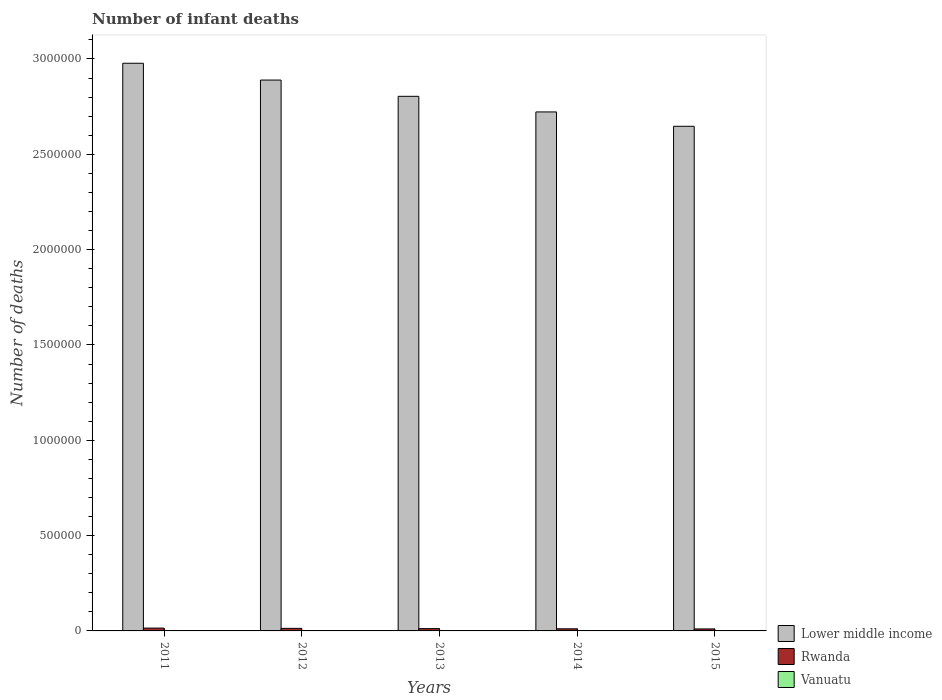How many groups of bars are there?
Make the answer very short. 5. Are the number of bars on each tick of the X-axis equal?
Ensure brevity in your answer.  Yes. How many bars are there on the 5th tick from the right?
Your response must be concise. 3. In how many cases, is the number of bars for a given year not equal to the number of legend labels?
Your answer should be compact. 0. What is the number of infant deaths in Lower middle income in 2015?
Keep it short and to the point. 2.65e+06. Across all years, what is the maximum number of infant deaths in Vanuatu?
Give a very brief answer. 187. Across all years, what is the minimum number of infant deaths in Vanuatu?
Make the answer very short. 157. In which year was the number of infant deaths in Lower middle income minimum?
Provide a short and direct response. 2015. What is the total number of infant deaths in Vanuatu in the graph?
Keep it short and to the point. 860. What is the difference between the number of infant deaths in Rwanda in 2012 and that in 2015?
Ensure brevity in your answer.  2923. What is the difference between the number of infant deaths in Rwanda in 2011 and the number of infant deaths in Vanuatu in 2015?
Ensure brevity in your answer.  1.46e+04. What is the average number of infant deaths in Lower middle income per year?
Provide a succinct answer. 2.81e+06. In the year 2012, what is the difference between the number of infant deaths in Rwanda and number of infant deaths in Vanuatu?
Make the answer very short. 1.32e+04. What is the ratio of the number of infant deaths in Rwanda in 2011 to that in 2014?
Make the answer very short. 1.33. Is the number of infant deaths in Vanuatu in 2012 less than that in 2015?
Keep it short and to the point. No. What is the difference between the highest and the lowest number of infant deaths in Lower middle income?
Provide a succinct answer. 3.31e+05. In how many years, is the number of infant deaths in Rwanda greater than the average number of infant deaths in Rwanda taken over all years?
Ensure brevity in your answer.  2. Is the sum of the number of infant deaths in Lower middle income in 2011 and 2013 greater than the maximum number of infant deaths in Vanuatu across all years?
Offer a very short reply. Yes. What does the 1st bar from the left in 2015 represents?
Keep it short and to the point. Lower middle income. What does the 3rd bar from the right in 2014 represents?
Your answer should be compact. Lower middle income. Are the values on the major ticks of Y-axis written in scientific E-notation?
Give a very brief answer. No. Does the graph contain any zero values?
Your answer should be very brief. No. Where does the legend appear in the graph?
Offer a terse response. Bottom right. How many legend labels are there?
Make the answer very short. 3. What is the title of the graph?
Provide a succinct answer. Number of infant deaths. What is the label or title of the X-axis?
Give a very brief answer. Years. What is the label or title of the Y-axis?
Keep it short and to the point. Number of deaths. What is the Number of deaths of Lower middle income in 2011?
Give a very brief answer. 2.98e+06. What is the Number of deaths in Rwanda in 2011?
Provide a short and direct response. 1.48e+04. What is the Number of deaths in Vanuatu in 2011?
Offer a very short reply. 187. What is the Number of deaths in Lower middle income in 2012?
Make the answer very short. 2.89e+06. What is the Number of deaths in Rwanda in 2012?
Your answer should be very brief. 1.34e+04. What is the Number of deaths in Vanuatu in 2012?
Provide a short and direct response. 181. What is the Number of deaths in Lower middle income in 2013?
Provide a short and direct response. 2.80e+06. What is the Number of deaths of Rwanda in 2013?
Your answer should be compact. 1.21e+04. What is the Number of deaths in Vanuatu in 2013?
Keep it short and to the point. 172. What is the Number of deaths of Lower middle income in 2014?
Your answer should be very brief. 2.72e+06. What is the Number of deaths of Rwanda in 2014?
Your response must be concise. 1.11e+04. What is the Number of deaths of Vanuatu in 2014?
Offer a very short reply. 163. What is the Number of deaths in Lower middle income in 2015?
Give a very brief answer. 2.65e+06. What is the Number of deaths of Rwanda in 2015?
Offer a very short reply. 1.04e+04. What is the Number of deaths in Vanuatu in 2015?
Your response must be concise. 157. Across all years, what is the maximum Number of deaths in Lower middle income?
Ensure brevity in your answer.  2.98e+06. Across all years, what is the maximum Number of deaths of Rwanda?
Your answer should be very brief. 1.48e+04. Across all years, what is the maximum Number of deaths of Vanuatu?
Give a very brief answer. 187. Across all years, what is the minimum Number of deaths in Lower middle income?
Offer a terse response. 2.65e+06. Across all years, what is the minimum Number of deaths in Rwanda?
Make the answer very short. 1.04e+04. Across all years, what is the minimum Number of deaths of Vanuatu?
Keep it short and to the point. 157. What is the total Number of deaths of Lower middle income in the graph?
Keep it short and to the point. 1.40e+07. What is the total Number of deaths of Rwanda in the graph?
Make the answer very short. 6.18e+04. What is the total Number of deaths in Vanuatu in the graph?
Provide a succinct answer. 860. What is the difference between the Number of deaths of Lower middle income in 2011 and that in 2012?
Offer a very short reply. 8.81e+04. What is the difference between the Number of deaths of Rwanda in 2011 and that in 2012?
Keep it short and to the point. 1383. What is the difference between the Number of deaths of Vanuatu in 2011 and that in 2012?
Offer a very short reply. 6. What is the difference between the Number of deaths in Lower middle income in 2011 and that in 2013?
Offer a terse response. 1.73e+05. What is the difference between the Number of deaths of Rwanda in 2011 and that in 2013?
Offer a terse response. 2629. What is the difference between the Number of deaths in Lower middle income in 2011 and that in 2014?
Your answer should be very brief. 2.55e+05. What is the difference between the Number of deaths in Rwanda in 2011 and that in 2014?
Provide a succinct answer. 3628. What is the difference between the Number of deaths in Vanuatu in 2011 and that in 2014?
Your response must be concise. 24. What is the difference between the Number of deaths in Lower middle income in 2011 and that in 2015?
Keep it short and to the point. 3.31e+05. What is the difference between the Number of deaths in Rwanda in 2011 and that in 2015?
Provide a succinct answer. 4306. What is the difference between the Number of deaths in Vanuatu in 2011 and that in 2015?
Provide a short and direct response. 30. What is the difference between the Number of deaths in Lower middle income in 2012 and that in 2013?
Ensure brevity in your answer.  8.53e+04. What is the difference between the Number of deaths in Rwanda in 2012 and that in 2013?
Make the answer very short. 1246. What is the difference between the Number of deaths in Vanuatu in 2012 and that in 2013?
Give a very brief answer. 9. What is the difference between the Number of deaths in Lower middle income in 2012 and that in 2014?
Offer a very short reply. 1.67e+05. What is the difference between the Number of deaths of Rwanda in 2012 and that in 2014?
Keep it short and to the point. 2245. What is the difference between the Number of deaths of Lower middle income in 2012 and that in 2015?
Provide a short and direct response. 2.43e+05. What is the difference between the Number of deaths of Rwanda in 2012 and that in 2015?
Offer a very short reply. 2923. What is the difference between the Number of deaths of Vanuatu in 2012 and that in 2015?
Make the answer very short. 24. What is the difference between the Number of deaths of Lower middle income in 2013 and that in 2014?
Make the answer very short. 8.19e+04. What is the difference between the Number of deaths in Rwanda in 2013 and that in 2014?
Ensure brevity in your answer.  999. What is the difference between the Number of deaths of Vanuatu in 2013 and that in 2014?
Your response must be concise. 9. What is the difference between the Number of deaths in Lower middle income in 2013 and that in 2015?
Your response must be concise. 1.57e+05. What is the difference between the Number of deaths of Rwanda in 2013 and that in 2015?
Make the answer very short. 1677. What is the difference between the Number of deaths of Lower middle income in 2014 and that in 2015?
Give a very brief answer. 7.53e+04. What is the difference between the Number of deaths in Rwanda in 2014 and that in 2015?
Keep it short and to the point. 678. What is the difference between the Number of deaths of Lower middle income in 2011 and the Number of deaths of Rwanda in 2012?
Your answer should be compact. 2.96e+06. What is the difference between the Number of deaths of Lower middle income in 2011 and the Number of deaths of Vanuatu in 2012?
Give a very brief answer. 2.98e+06. What is the difference between the Number of deaths in Rwanda in 2011 and the Number of deaths in Vanuatu in 2012?
Offer a terse response. 1.46e+04. What is the difference between the Number of deaths of Lower middle income in 2011 and the Number of deaths of Rwanda in 2013?
Your response must be concise. 2.97e+06. What is the difference between the Number of deaths in Lower middle income in 2011 and the Number of deaths in Vanuatu in 2013?
Provide a short and direct response. 2.98e+06. What is the difference between the Number of deaths of Rwanda in 2011 and the Number of deaths of Vanuatu in 2013?
Offer a terse response. 1.46e+04. What is the difference between the Number of deaths of Lower middle income in 2011 and the Number of deaths of Rwanda in 2014?
Offer a terse response. 2.97e+06. What is the difference between the Number of deaths of Lower middle income in 2011 and the Number of deaths of Vanuatu in 2014?
Make the answer very short. 2.98e+06. What is the difference between the Number of deaths of Rwanda in 2011 and the Number of deaths of Vanuatu in 2014?
Offer a very short reply. 1.46e+04. What is the difference between the Number of deaths in Lower middle income in 2011 and the Number of deaths in Rwanda in 2015?
Your answer should be very brief. 2.97e+06. What is the difference between the Number of deaths in Lower middle income in 2011 and the Number of deaths in Vanuatu in 2015?
Ensure brevity in your answer.  2.98e+06. What is the difference between the Number of deaths of Rwanda in 2011 and the Number of deaths of Vanuatu in 2015?
Your answer should be very brief. 1.46e+04. What is the difference between the Number of deaths of Lower middle income in 2012 and the Number of deaths of Rwanda in 2013?
Ensure brevity in your answer.  2.88e+06. What is the difference between the Number of deaths in Lower middle income in 2012 and the Number of deaths in Vanuatu in 2013?
Your answer should be compact. 2.89e+06. What is the difference between the Number of deaths in Rwanda in 2012 and the Number of deaths in Vanuatu in 2013?
Offer a terse response. 1.32e+04. What is the difference between the Number of deaths in Lower middle income in 2012 and the Number of deaths in Rwanda in 2014?
Provide a short and direct response. 2.88e+06. What is the difference between the Number of deaths in Lower middle income in 2012 and the Number of deaths in Vanuatu in 2014?
Offer a terse response. 2.89e+06. What is the difference between the Number of deaths of Rwanda in 2012 and the Number of deaths of Vanuatu in 2014?
Provide a succinct answer. 1.32e+04. What is the difference between the Number of deaths in Lower middle income in 2012 and the Number of deaths in Rwanda in 2015?
Offer a very short reply. 2.88e+06. What is the difference between the Number of deaths of Lower middle income in 2012 and the Number of deaths of Vanuatu in 2015?
Your answer should be compact. 2.89e+06. What is the difference between the Number of deaths of Rwanda in 2012 and the Number of deaths of Vanuatu in 2015?
Keep it short and to the point. 1.32e+04. What is the difference between the Number of deaths of Lower middle income in 2013 and the Number of deaths of Rwanda in 2014?
Offer a very short reply. 2.79e+06. What is the difference between the Number of deaths in Lower middle income in 2013 and the Number of deaths in Vanuatu in 2014?
Make the answer very short. 2.80e+06. What is the difference between the Number of deaths of Rwanda in 2013 and the Number of deaths of Vanuatu in 2014?
Offer a terse response. 1.20e+04. What is the difference between the Number of deaths in Lower middle income in 2013 and the Number of deaths in Rwanda in 2015?
Provide a short and direct response. 2.79e+06. What is the difference between the Number of deaths of Lower middle income in 2013 and the Number of deaths of Vanuatu in 2015?
Your response must be concise. 2.80e+06. What is the difference between the Number of deaths of Rwanda in 2013 and the Number of deaths of Vanuatu in 2015?
Your response must be concise. 1.20e+04. What is the difference between the Number of deaths of Lower middle income in 2014 and the Number of deaths of Rwanda in 2015?
Keep it short and to the point. 2.71e+06. What is the difference between the Number of deaths in Lower middle income in 2014 and the Number of deaths in Vanuatu in 2015?
Keep it short and to the point. 2.72e+06. What is the difference between the Number of deaths in Rwanda in 2014 and the Number of deaths in Vanuatu in 2015?
Your response must be concise. 1.10e+04. What is the average Number of deaths in Lower middle income per year?
Your answer should be very brief. 2.81e+06. What is the average Number of deaths of Rwanda per year?
Your response must be concise. 1.24e+04. What is the average Number of deaths of Vanuatu per year?
Your response must be concise. 172. In the year 2011, what is the difference between the Number of deaths in Lower middle income and Number of deaths in Rwanda?
Provide a succinct answer. 2.96e+06. In the year 2011, what is the difference between the Number of deaths in Lower middle income and Number of deaths in Vanuatu?
Your response must be concise. 2.98e+06. In the year 2011, what is the difference between the Number of deaths of Rwanda and Number of deaths of Vanuatu?
Your response must be concise. 1.46e+04. In the year 2012, what is the difference between the Number of deaths of Lower middle income and Number of deaths of Rwanda?
Provide a short and direct response. 2.88e+06. In the year 2012, what is the difference between the Number of deaths of Lower middle income and Number of deaths of Vanuatu?
Provide a short and direct response. 2.89e+06. In the year 2012, what is the difference between the Number of deaths of Rwanda and Number of deaths of Vanuatu?
Give a very brief answer. 1.32e+04. In the year 2013, what is the difference between the Number of deaths of Lower middle income and Number of deaths of Rwanda?
Provide a succinct answer. 2.79e+06. In the year 2013, what is the difference between the Number of deaths in Lower middle income and Number of deaths in Vanuatu?
Give a very brief answer. 2.80e+06. In the year 2013, what is the difference between the Number of deaths in Rwanda and Number of deaths in Vanuatu?
Make the answer very short. 1.20e+04. In the year 2014, what is the difference between the Number of deaths in Lower middle income and Number of deaths in Rwanda?
Keep it short and to the point. 2.71e+06. In the year 2014, what is the difference between the Number of deaths in Lower middle income and Number of deaths in Vanuatu?
Give a very brief answer. 2.72e+06. In the year 2014, what is the difference between the Number of deaths of Rwanda and Number of deaths of Vanuatu?
Provide a short and direct response. 1.10e+04. In the year 2015, what is the difference between the Number of deaths of Lower middle income and Number of deaths of Rwanda?
Ensure brevity in your answer.  2.64e+06. In the year 2015, what is the difference between the Number of deaths in Lower middle income and Number of deaths in Vanuatu?
Ensure brevity in your answer.  2.65e+06. In the year 2015, what is the difference between the Number of deaths of Rwanda and Number of deaths of Vanuatu?
Make the answer very short. 1.03e+04. What is the ratio of the Number of deaths of Lower middle income in 2011 to that in 2012?
Give a very brief answer. 1.03. What is the ratio of the Number of deaths in Rwanda in 2011 to that in 2012?
Ensure brevity in your answer.  1.1. What is the ratio of the Number of deaths in Vanuatu in 2011 to that in 2012?
Keep it short and to the point. 1.03. What is the ratio of the Number of deaths of Lower middle income in 2011 to that in 2013?
Provide a short and direct response. 1.06. What is the ratio of the Number of deaths of Rwanda in 2011 to that in 2013?
Your answer should be very brief. 1.22. What is the ratio of the Number of deaths in Vanuatu in 2011 to that in 2013?
Ensure brevity in your answer.  1.09. What is the ratio of the Number of deaths of Lower middle income in 2011 to that in 2014?
Your answer should be very brief. 1.09. What is the ratio of the Number of deaths in Rwanda in 2011 to that in 2014?
Provide a short and direct response. 1.33. What is the ratio of the Number of deaths in Vanuatu in 2011 to that in 2014?
Provide a short and direct response. 1.15. What is the ratio of the Number of deaths of Lower middle income in 2011 to that in 2015?
Your answer should be compact. 1.12. What is the ratio of the Number of deaths of Rwanda in 2011 to that in 2015?
Ensure brevity in your answer.  1.41. What is the ratio of the Number of deaths in Vanuatu in 2011 to that in 2015?
Provide a short and direct response. 1.19. What is the ratio of the Number of deaths in Lower middle income in 2012 to that in 2013?
Your response must be concise. 1.03. What is the ratio of the Number of deaths in Rwanda in 2012 to that in 2013?
Keep it short and to the point. 1.1. What is the ratio of the Number of deaths in Vanuatu in 2012 to that in 2013?
Provide a succinct answer. 1.05. What is the ratio of the Number of deaths of Lower middle income in 2012 to that in 2014?
Make the answer very short. 1.06. What is the ratio of the Number of deaths of Rwanda in 2012 to that in 2014?
Your response must be concise. 1.2. What is the ratio of the Number of deaths of Vanuatu in 2012 to that in 2014?
Your response must be concise. 1.11. What is the ratio of the Number of deaths in Lower middle income in 2012 to that in 2015?
Offer a very short reply. 1.09. What is the ratio of the Number of deaths of Rwanda in 2012 to that in 2015?
Keep it short and to the point. 1.28. What is the ratio of the Number of deaths in Vanuatu in 2012 to that in 2015?
Keep it short and to the point. 1.15. What is the ratio of the Number of deaths of Lower middle income in 2013 to that in 2014?
Keep it short and to the point. 1.03. What is the ratio of the Number of deaths in Rwanda in 2013 to that in 2014?
Offer a terse response. 1.09. What is the ratio of the Number of deaths of Vanuatu in 2013 to that in 2014?
Make the answer very short. 1.06. What is the ratio of the Number of deaths of Lower middle income in 2013 to that in 2015?
Offer a very short reply. 1.06. What is the ratio of the Number of deaths in Rwanda in 2013 to that in 2015?
Offer a terse response. 1.16. What is the ratio of the Number of deaths in Vanuatu in 2013 to that in 2015?
Your response must be concise. 1.1. What is the ratio of the Number of deaths of Lower middle income in 2014 to that in 2015?
Ensure brevity in your answer.  1.03. What is the ratio of the Number of deaths of Rwanda in 2014 to that in 2015?
Offer a terse response. 1.06. What is the ratio of the Number of deaths in Vanuatu in 2014 to that in 2015?
Give a very brief answer. 1.04. What is the difference between the highest and the second highest Number of deaths of Lower middle income?
Offer a terse response. 8.81e+04. What is the difference between the highest and the second highest Number of deaths of Rwanda?
Give a very brief answer. 1383. What is the difference between the highest and the lowest Number of deaths of Lower middle income?
Offer a terse response. 3.31e+05. What is the difference between the highest and the lowest Number of deaths in Rwanda?
Keep it short and to the point. 4306. What is the difference between the highest and the lowest Number of deaths of Vanuatu?
Keep it short and to the point. 30. 